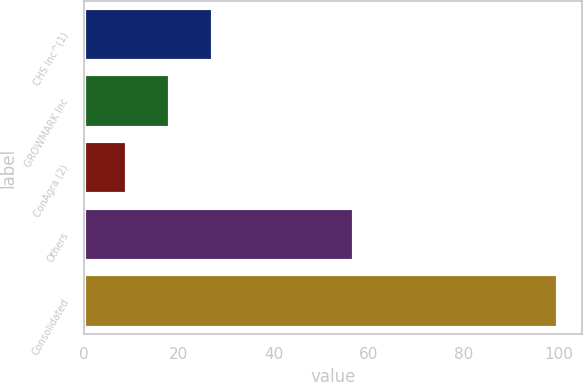<chart> <loc_0><loc_0><loc_500><loc_500><bar_chart><fcel>CHS Inc^(1)<fcel>GROWMARK Inc<fcel>ConAgra (2)<fcel>Others<fcel>Consolidated<nl><fcel>27.2<fcel>18.1<fcel>9<fcel>57<fcel>100<nl></chart> 